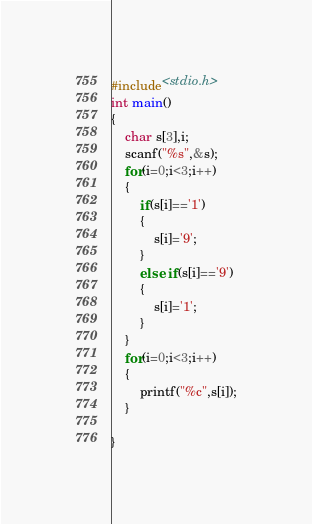Convert code to text. <code><loc_0><loc_0><loc_500><loc_500><_C_>#include<stdio.h>
int main()
{
    char s[3],i;
    scanf("%s",&s);
    for(i=0;i<3;i++)
    {
        if(s[i]=='1')
        {
            s[i]='9';
        }
        else if(s[i]=='9')
        {
            s[i]='1';
        }
    }
    for(i=0;i<3;i++)
    {
        printf("%c",s[i]);
    }

}
</code> 